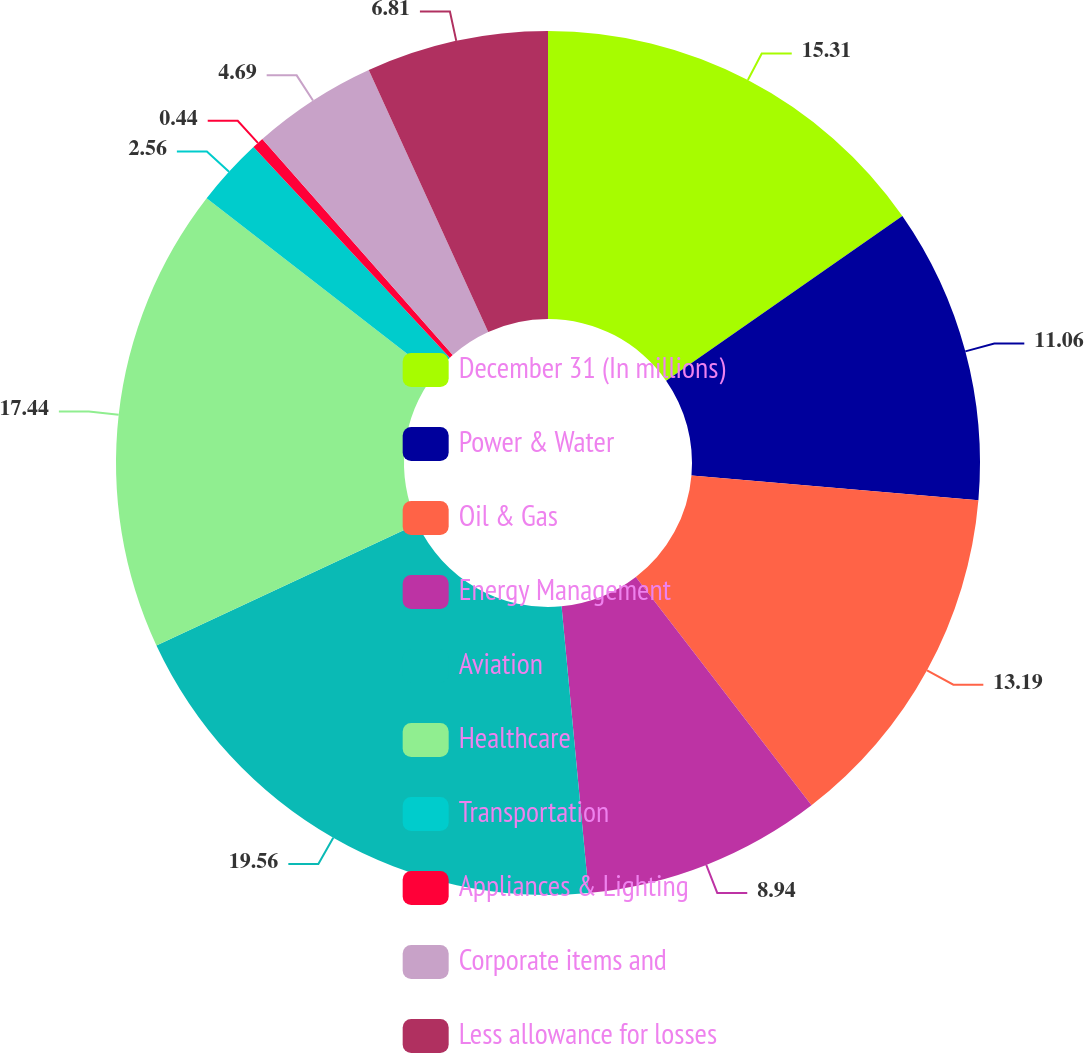Convert chart. <chart><loc_0><loc_0><loc_500><loc_500><pie_chart><fcel>December 31 (In millions)<fcel>Power & Water<fcel>Oil & Gas<fcel>Energy Management<fcel>Aviation<fcel>Healthcare<fcel>Transportation<fcel>Appliances & Lighting<fcel>Corporate items and<fcel>Less allowance for losses<nl><fcel>15.31%<fcel>11.06%<fcel>13.19%<fcel>8.94%<fcel>19.56%<fcel>17.44%<fcel>2.56%<fcel>0.44%<fcel>4.69%<fcel>6.81%<nl></chart> 